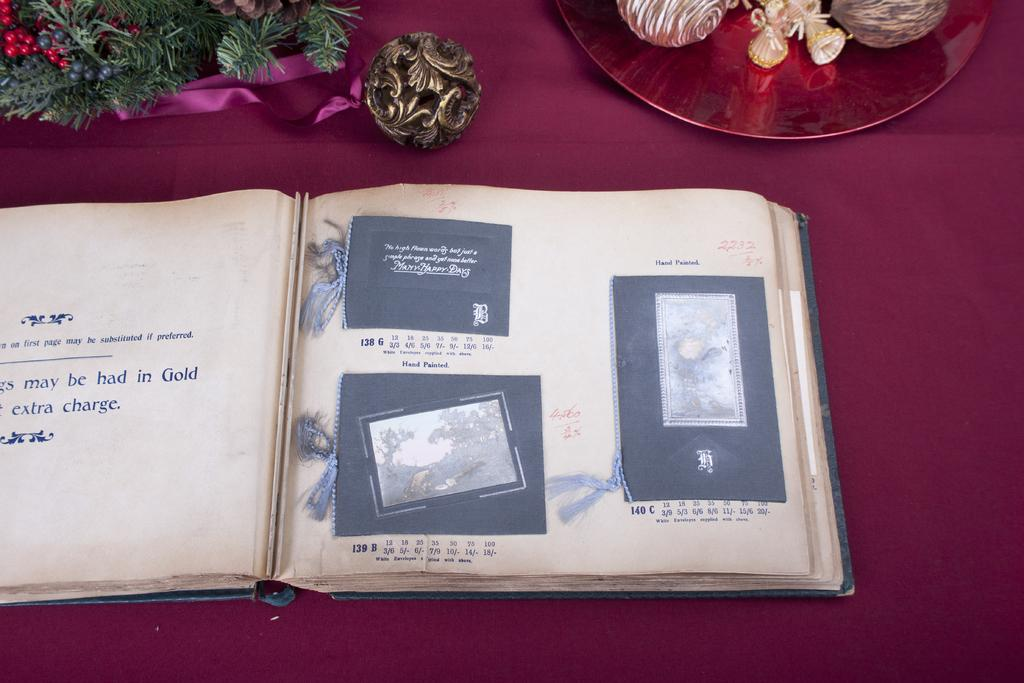<image>
Give a short and clear explanation of the subsequent image. The two items on the right hand page are hand painted. 